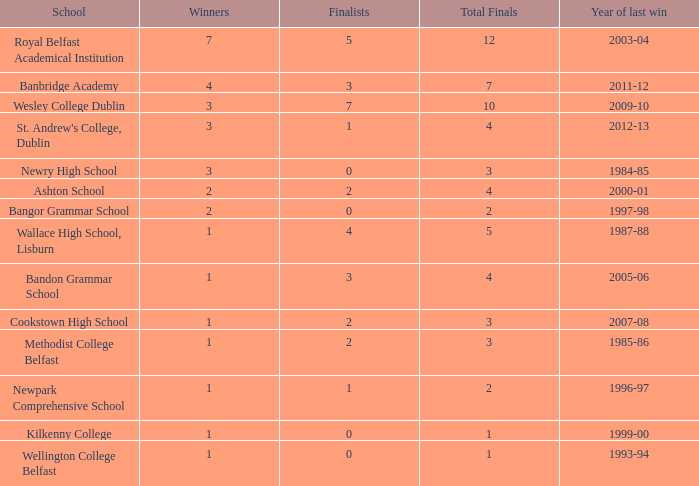What is the name of the school that had its most recent victory in the 2007-08 season? Cookstown High School. 